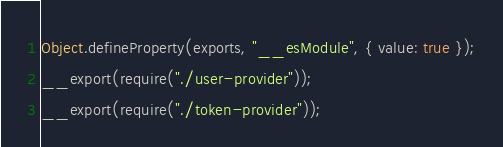Convert code to text. <code><loc_0><loc_0><loc_500><loc_500><_JavaScript_>Object.defineProperty(exports, "__esModule", { value: true });
__export(require("./user-provider"));
__export(require("./token-provider"));
</code> 